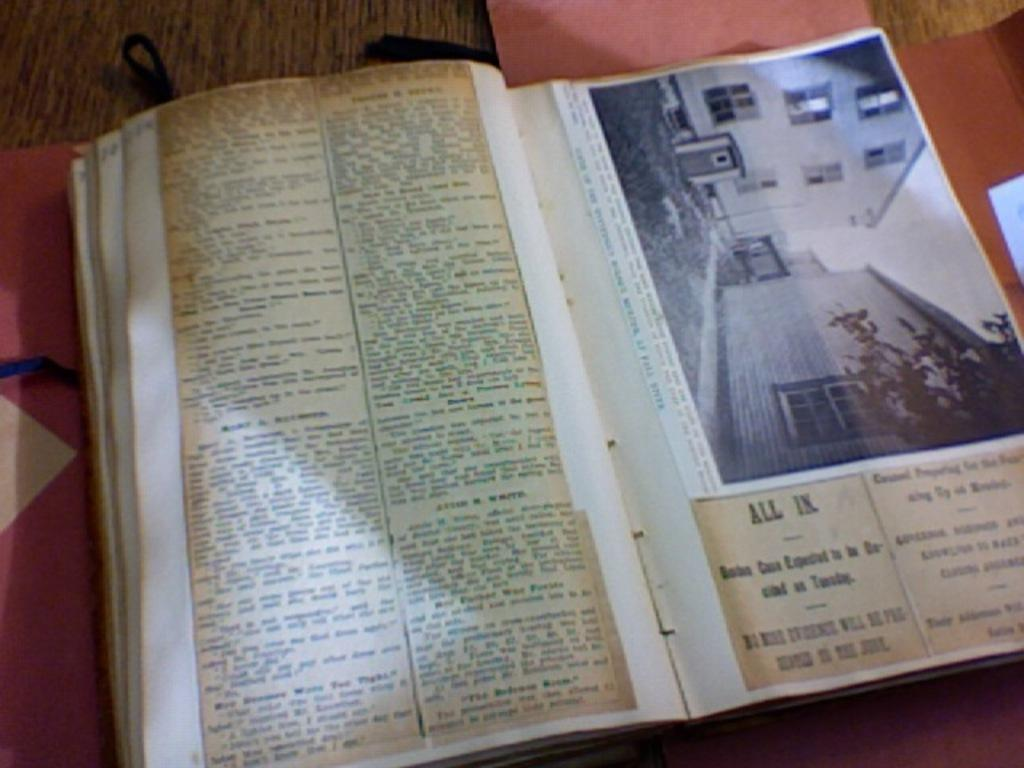<image>
Present a compact description of the photo's key features. A book of newspaper clippings. One of the headlines reads All In 